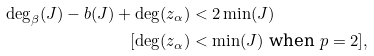Convert formula to latex. <formula><loc_0><loc_0><loc_500><loc_500>\deg _ { \beta } ( J ) - b ( J ) + \deg ( z _ { \alpha } ) & < 2 \min ( J ) \\ [ \deg ( z _ { \alpha } ) & < \min ( J ) \text { when $p=2$} ] ,</formula> 